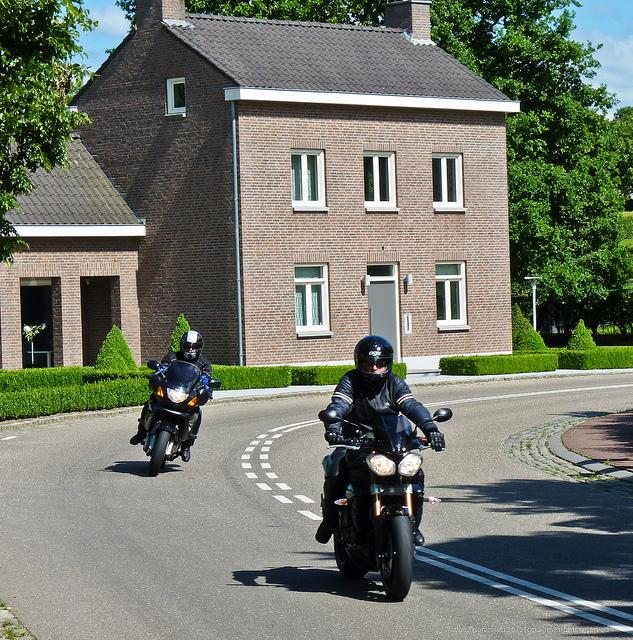What color are the stripes on the sleeves of the jacket worn by the motorcyclist in front? white 